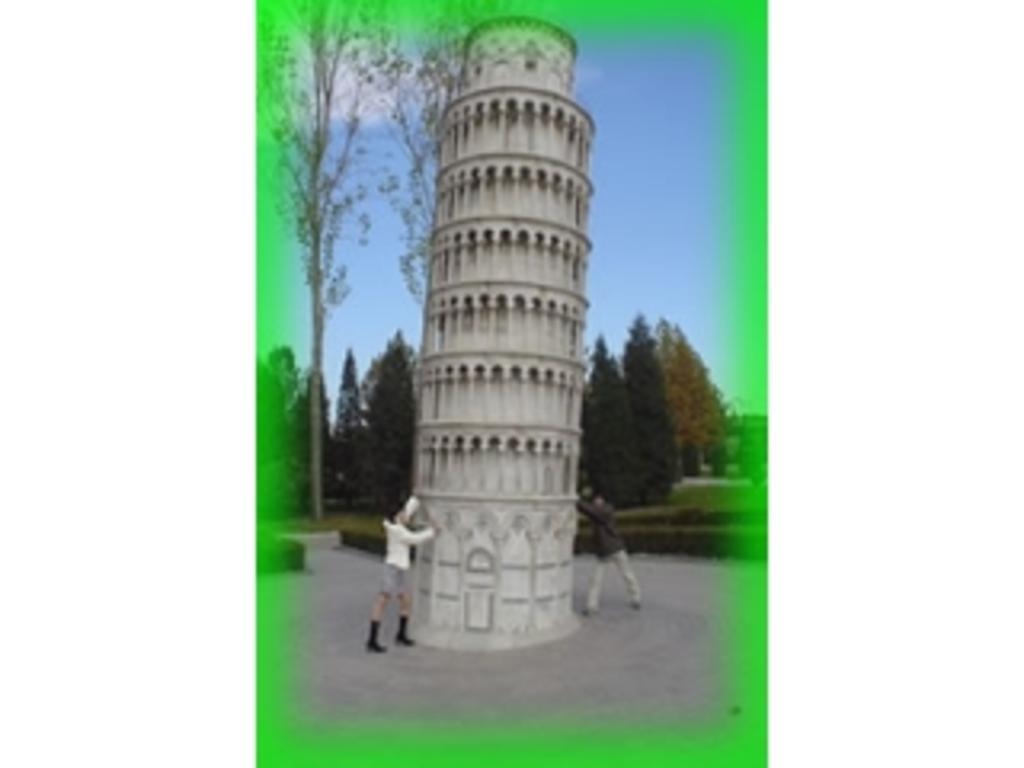Describe this image in one or two sentences. In this picture there is a tower and there are two persons touching the tower. In the background there are trees and sky. 